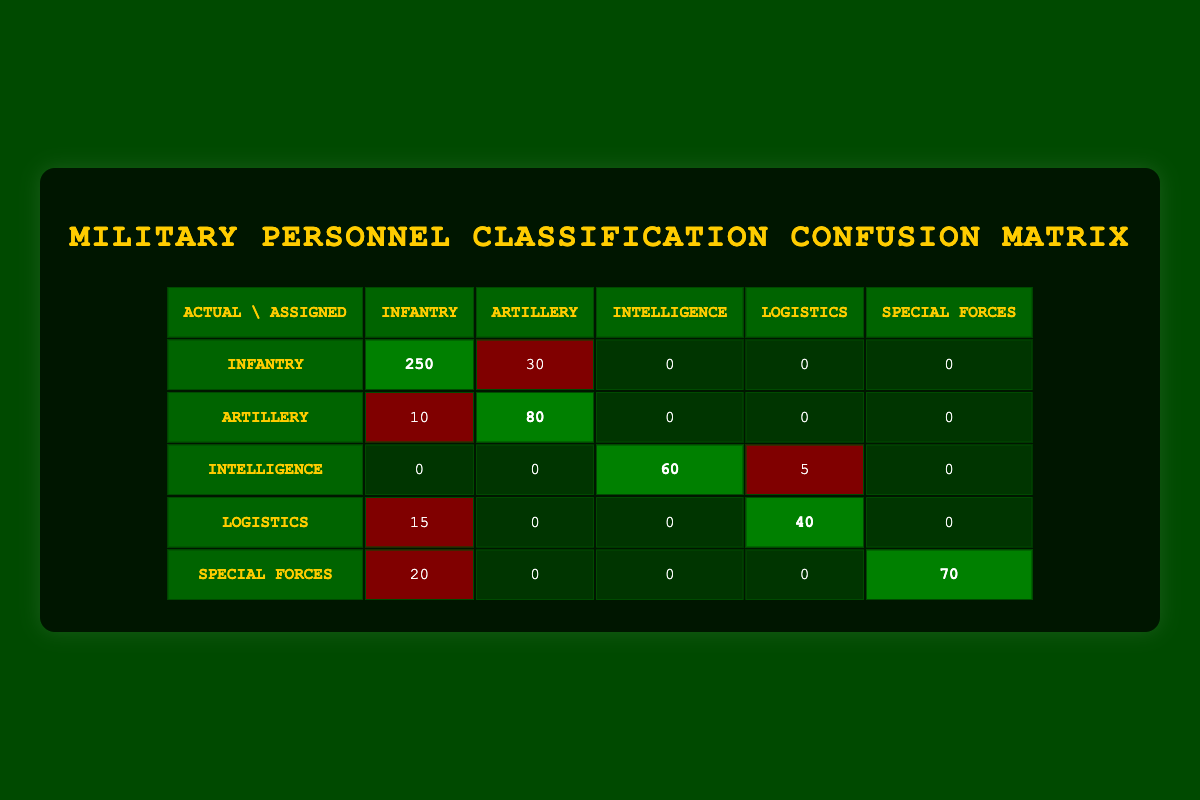What is the total number of Infantry personnel assigned to the Infantry role? The table shows that 250 personnel are assigned to the Infantry role under the actual category of Infantry. Therefore, the total for Infantry in the assigned column is 250.
Answer: 250 How many Artillery personnel were misclassified as Infantry? The table indicates that 10 personnel who were actually Artillery were assigned to the Infantry role, thus indicating a misclassification.
Answer: 10 What is the total number of personnel in the Logistics role, both correctly and incorrectly assigned? The table shows that there are 40 personnel correctly assigned to Logistics and 15 misclassified as Infantry. Adding these together gives a total of 55 personnel in the Logistics role.
Answer: 55 Is the number of Special Forces assigned to the Special Forces role greater than the number of Logistics assigned to Logistics? The table indicates that 70 personnel are assigned to Special Forces, while 40 personnel are assigned to Logistics. Thus, 70 is greater than 40, making the statement true.
Answer: Yes If we consider the total number of Infantry personnel, how many were not assigned correctly? The total number of Infantry personnel is 250 assigned correctly, plus 30 misclassified as Artillery, totaling 280. Thus, 30 personnel were not assigned correctly (30 out of 280).
Answer: 30 